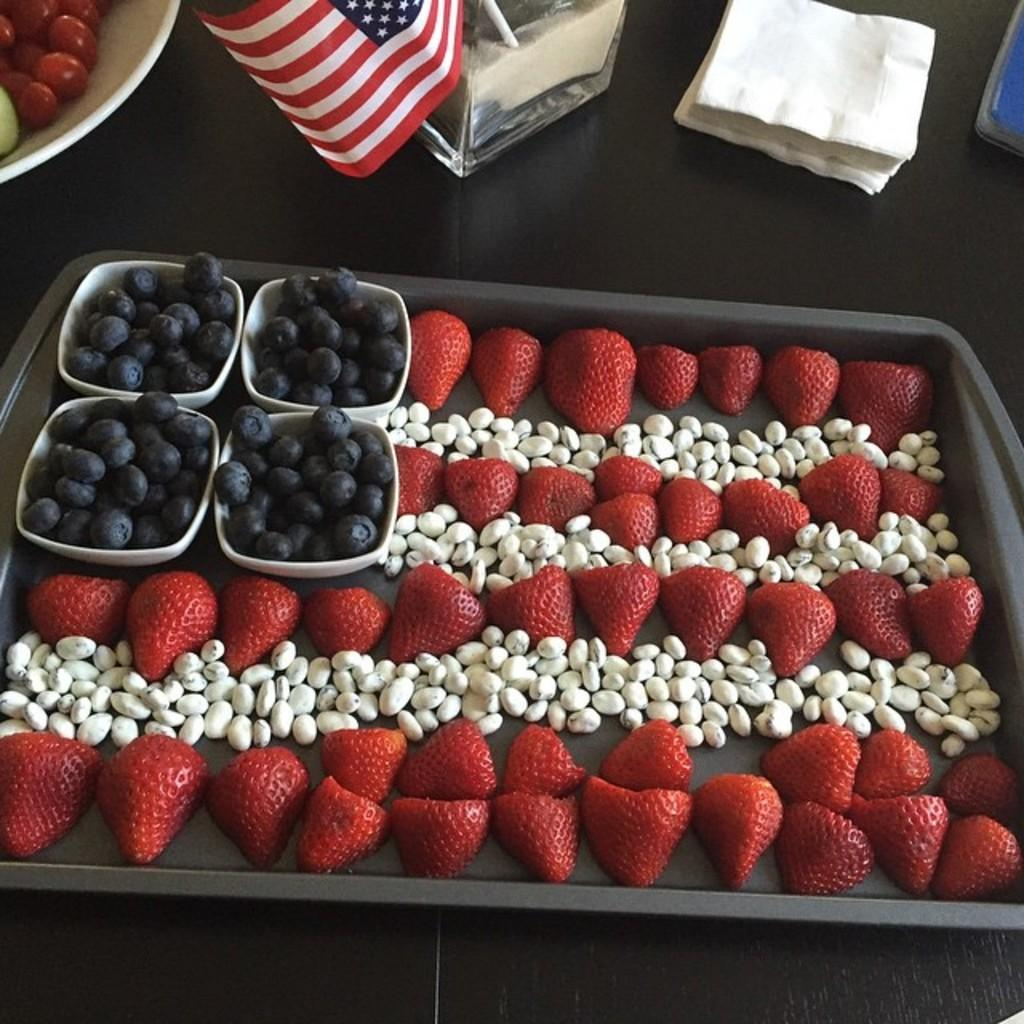What type of fruit can be seen in the image? There are strawberries and black grapes in the image. How are the strawberries and black grapes arranged in the image? The strawberries and black grapes are in a black color tray. What is the tray placed on in the image? The tray is placed on a wooden table. What other item can be seen in the image related to the American flag? There are tissue papers in the image. What song is being sung by the strawberries in the image? There is no indication in the image that the strawberries are singing a song. 